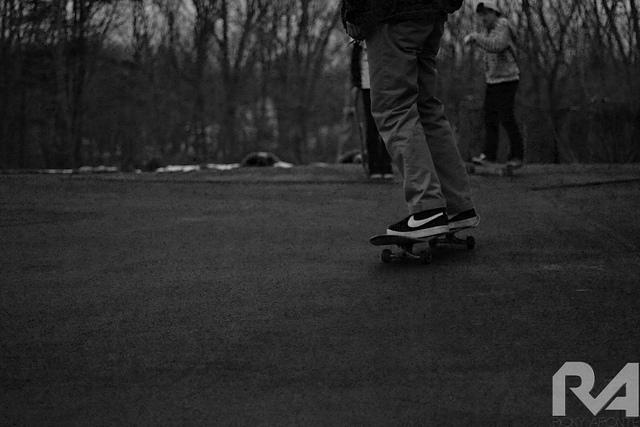Is this person wearing pants or shorts?
Short answer required. Pants. Is this scene happening during the day?
Short answer required. No. Is the weather warm?
Keep it brief. No. What type of sneaker's does the person have?
Answer briefly. Nike. Is this a professional picture?
Be succinct. No. Is his feet on the skateboard?
Quick response, please. Yes. What color are the wheels?
Keep it brief. Black. Is that a nice car?
Give a very brief answer. No. What brand of shoes is the subject wearing?
Short answer required. Nike. Is there any one seated in the scene?
Short answer required. No. What is the website in the picture?
Be succinct. Ra. What type of sport is being played?
Quick response, please. Skateboarding. 